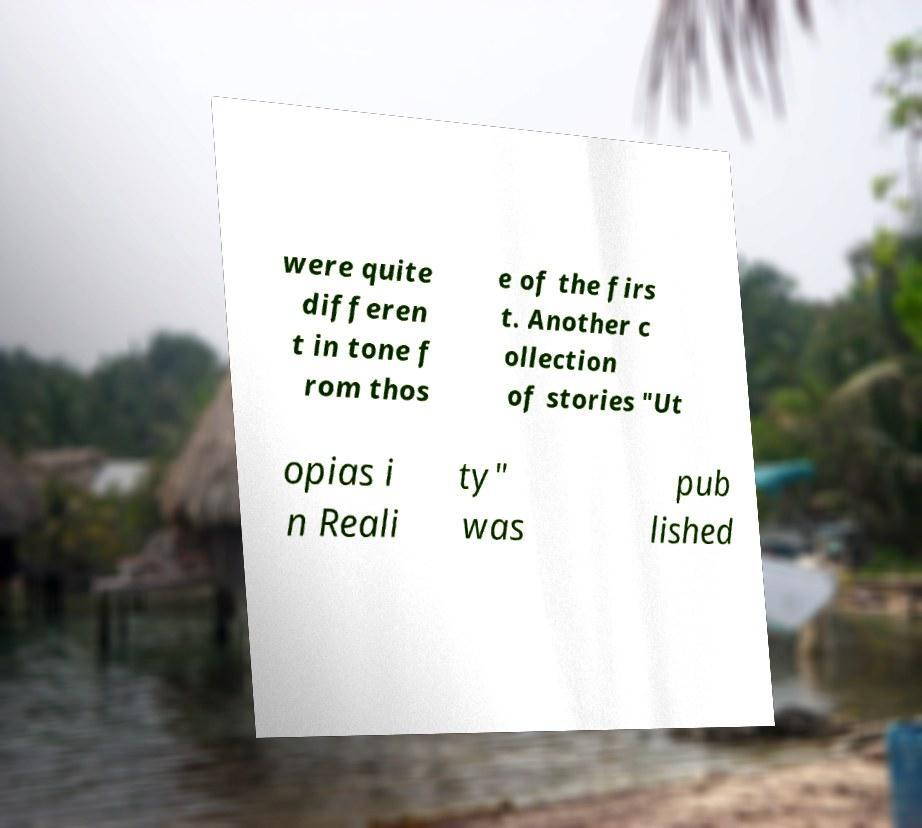Could you extract and type out the text from this image? were quite differen t in tone f rom thos e of the firs t. Another c ollection of stories "Ut opias i n Reali ty" was pub lished 